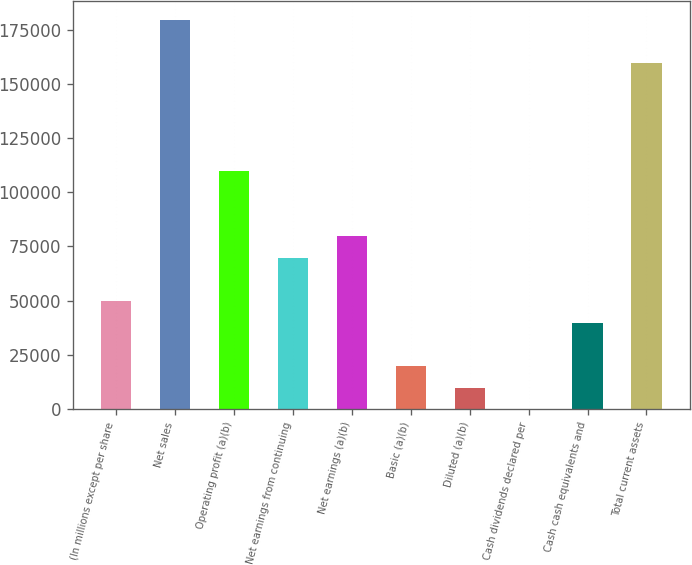Convert chart to OTSL. <chart><loc_0><loc_0><loc_500><loc_500><bar_chart><fcel>(In millions except per share<fcel>Net sales<fcel>Operating profit (a)(b)<fcel>Net earnings from continuing<fcel>Net earnings (a)(b)<fcel>Basic (a)(b)<fcel>Diluted (a)(b)<fcel>Cash dividends declared per<fcel>Cash cash equivalents and<fcel>Total current assets<nl><fcel>49803.1<fcel>179275<fcel>109559<fcel>69721.9<fcel>79681.3<fcel>19924.9<fcel>9965.54<fcel>6.15<fcel>39843.7<fcel>159356<nl></chart> 